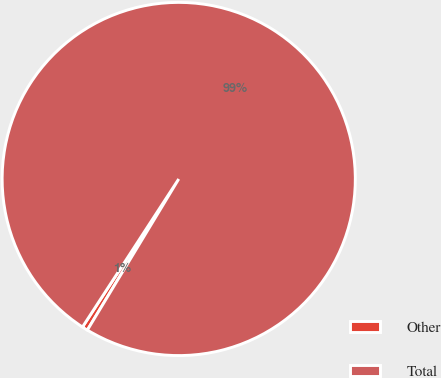Convert chart to OTSL. <chart><loc_0><loc_0><loc_500><loc_500><pie_chart><fcel>Other<fcel>Total<nl><fcel>0.52%<fcel>99.48%<nl></chart> 